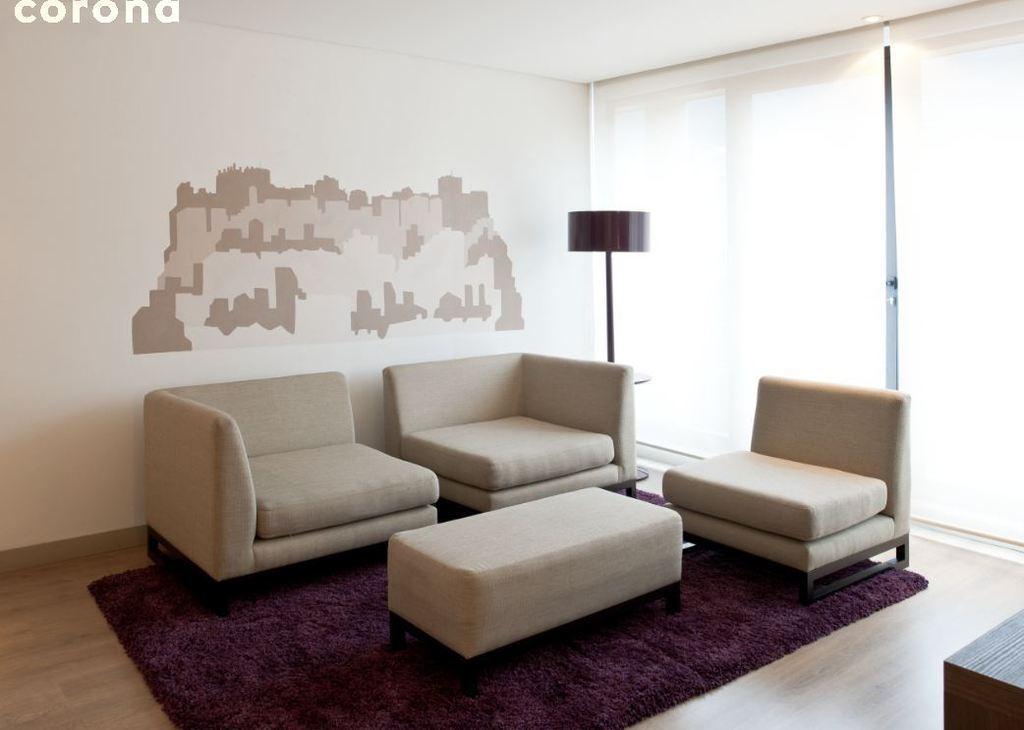Can you describe this image briefly? Here in this picture we can see chairs and a table present on the floor and we can also see a lamp present and we can also see glass windows covered with curtains. 